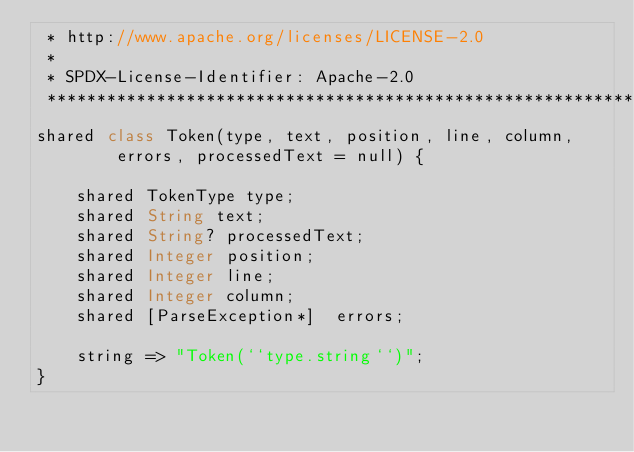Convert code to text. <code><loc_0><loc_0><loc_500><loc_500><_Ceylon_> * http://www.apache.org/licenses/LICENSE-2.0
 *
 * SPDX-License-Identifier: Apache-2.0 
 ********************************************************************************/
shared class Token(type, text, position, line, column,
        errors, processedText = null) {

    shared TokenType type;
    shared String text;
    shared String? processedText;
    shared Integer position;
    shared Integer line;
    shared Integer column;
    shared [ParseException*]  errors;

    string => "Token(``type.string``)";
}
</code> 